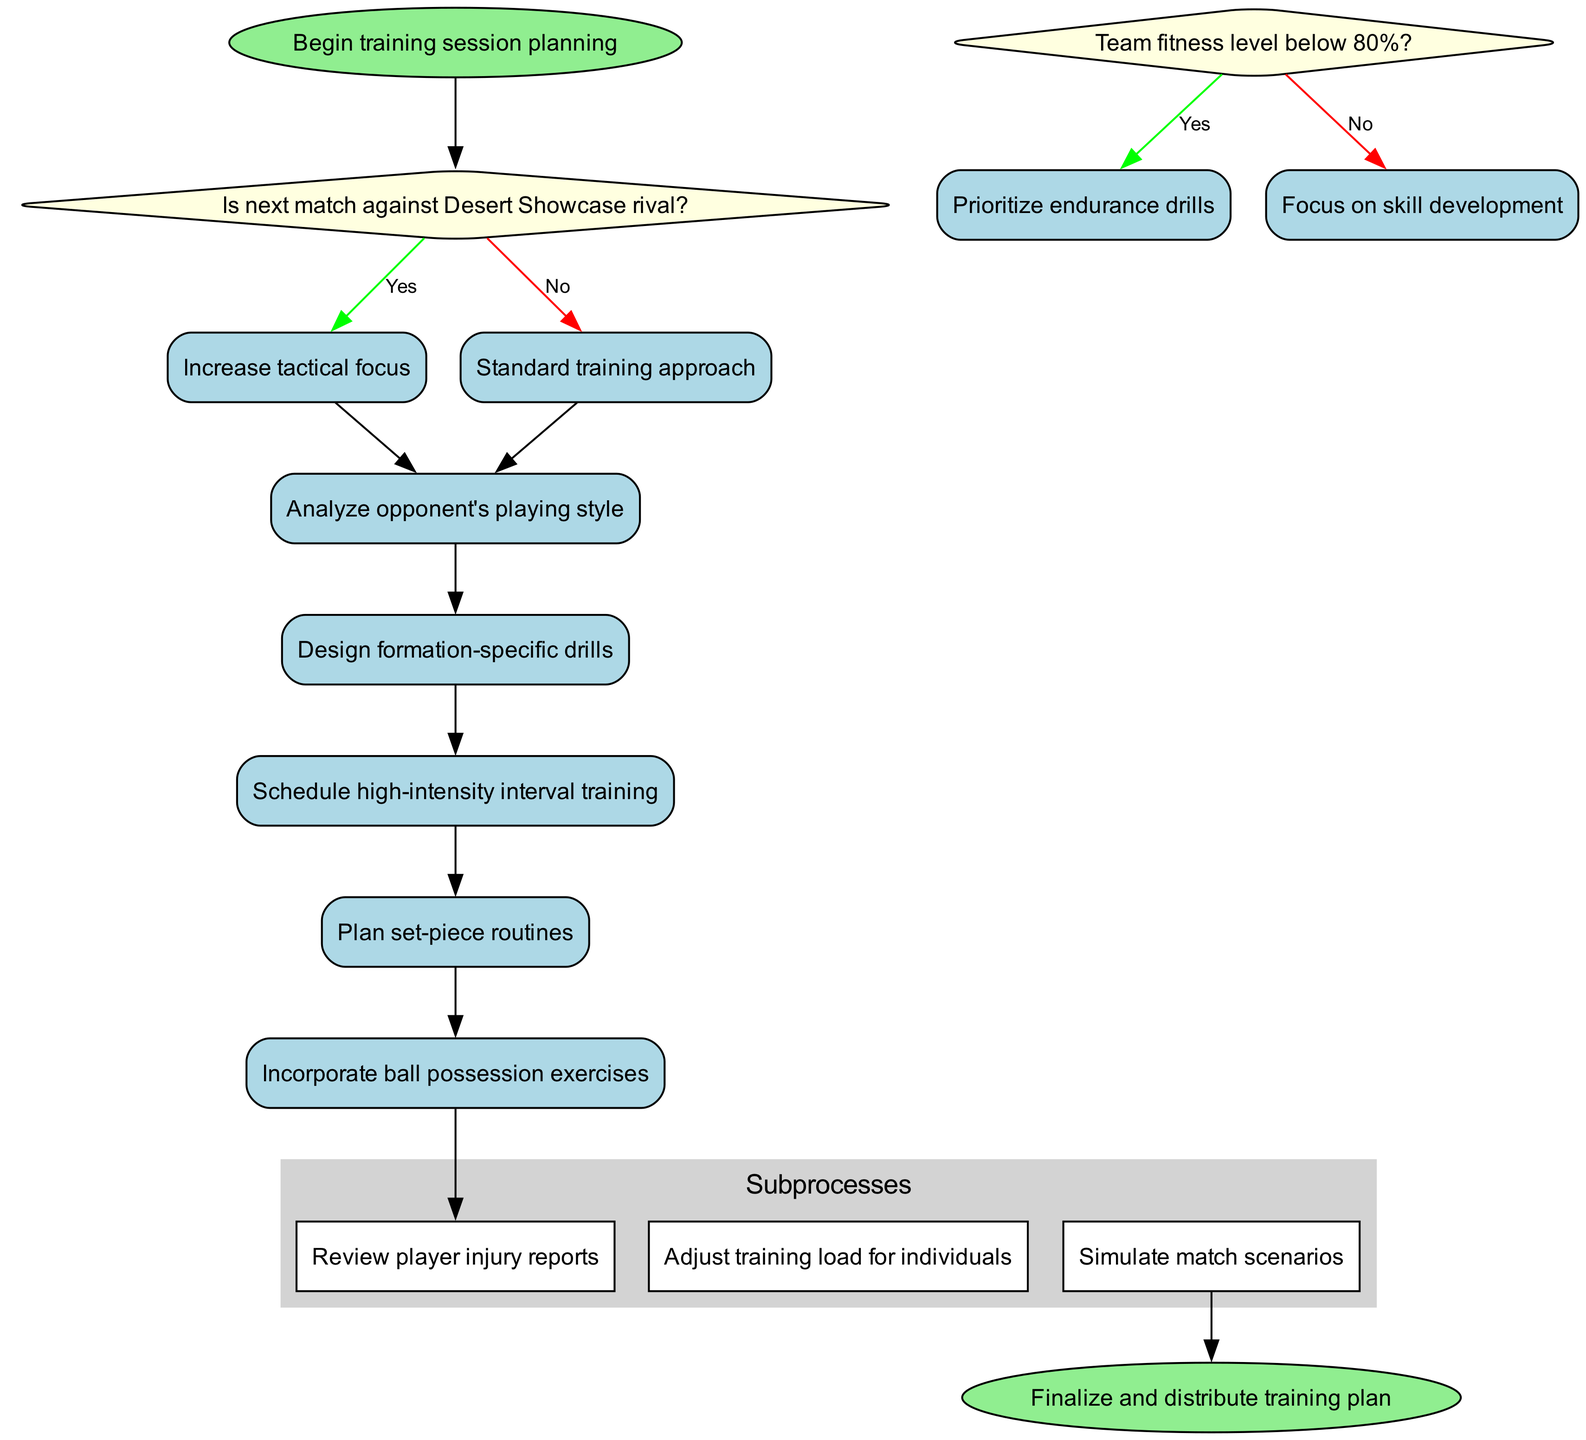What is the first process in the training session planning algorithm? The first process is listed in the 'processes' section of the diagram, where it states "Analyze opponent's playing style". This node follows the decisions and is the first on the flowchart.
Answer: Analyze opponent's playing style How many decision nodes are in the diagram? There are two decision nodes according to the 'decisions' section, each of which presents a conditional question that branches into two different actions based on the answers.
Answer: 2 What happens if the team's fitness level is below 80%? According to the flowchart, if the fitness level is below 80%, the subsequent action is to "Prioritize endurance drills", which is specified in the decision node related to fitness.
Answer: Prioritize endurance drills What is the end node labeled as? The end node at the conclusion of the diagram is simply labeled as "Finalize and distribute training plan", which marks the completion of the training session planning process.
Answer: Finalize and distribute training plan What should be done if the next match is against a Desert Showcase rival? The decision indicates that if the next match is against a rival, the focus should be on tactics, specifically stating "Increase tactical focus", which is the outcome of that decision node.
Answer: Increase tactical focus Which subprocess follows the main processes in the flowchart? After the main processes are specified, the subprocesses start with "Review player injury reports". This shows a branch from the last main process to provide additional detail about the training session.
Answer: Review player injury reports How many total processes are in the algorithm? The algorithm outlines a total of five processes that focus on specific training aspects necessary for developing the team. This total can be counted from the 'processes' section of the diagram.
Answer: 5 What is the purpose of the "Simulate match scenarios" subprocess? The subprocess "Simulate match scenarios" is intended to create practice conditions that mimic actual match situations, enhancing players' readiness for real game events, and is included in the subprocesses section.
Answer: Prepare for match conditions 